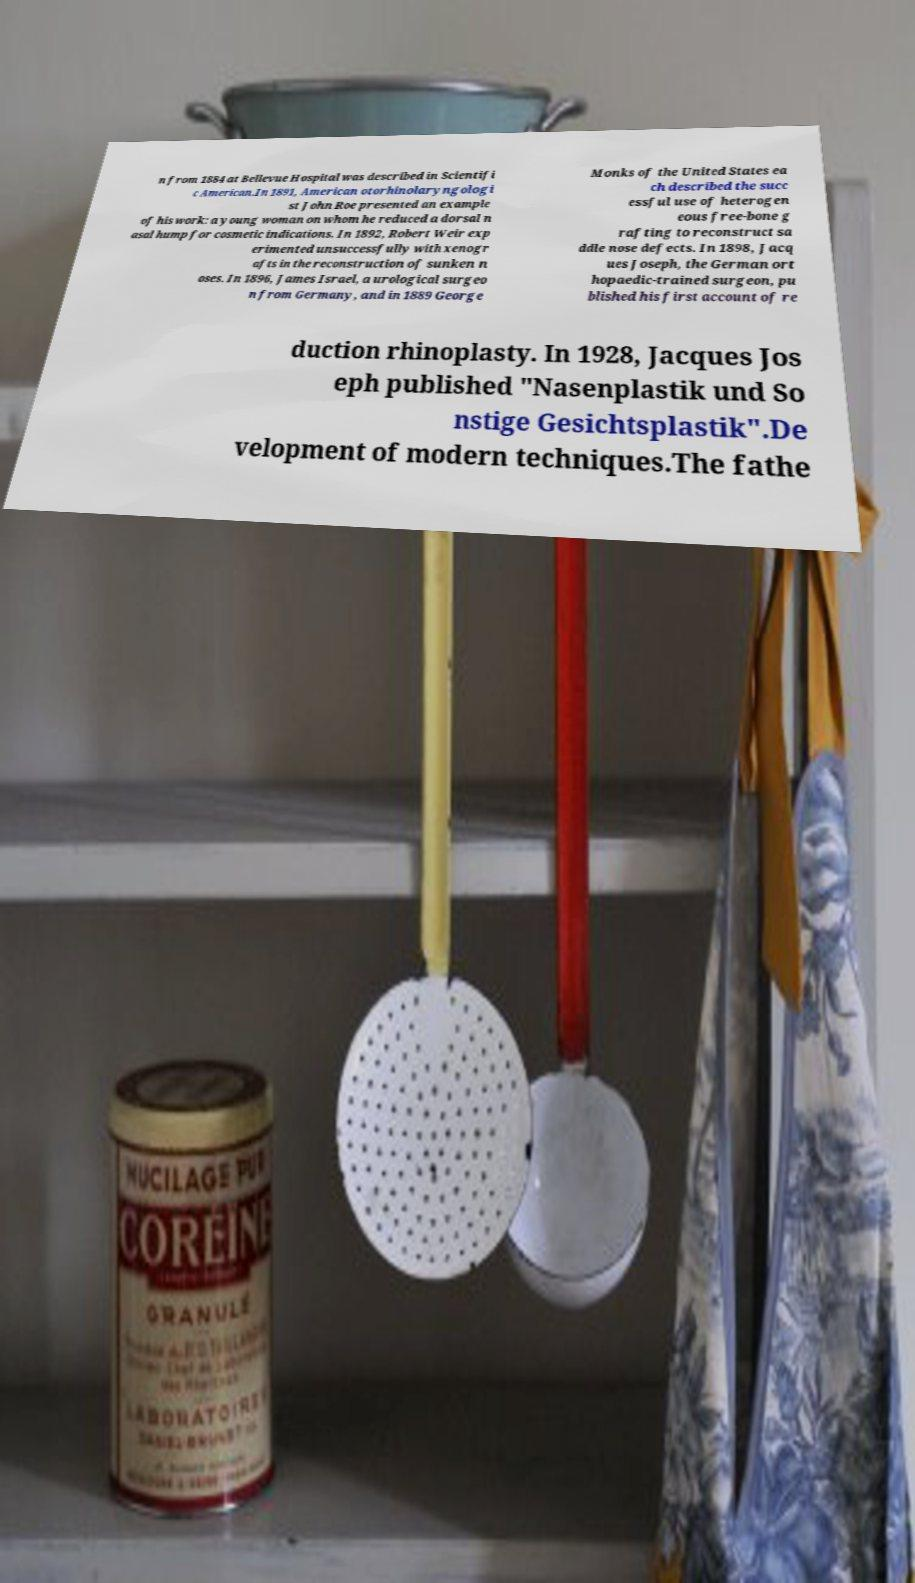Please identify and transcribe the text found in this image. n from 1884 at Bellevue Hospital was described in Scientifi c American.In 1891, American otorhinolaryngologi st John Roe presented an example of his work: a young woman on whom he reduced a dorsal n asal hump for cosmetic indications. In 1892, Robert Weir exp erimented unsuccessfully with xenogr afts in the reconstruction of sunken n oses. In 1896, James Israel, a urological surgeo n from Germany, and in 1889 George Monks of the United States ea ch described the succ essful use of heterogen eous free-bone g rafting to reconstruct sa ddle nose defects. In 1898, Jacq ues Joseph, the German ort hopaedic-trained surgeon, pu blished his first account of re duction rhinoplasty. In 1928, Jacques Jos eph published "Nasenplastik und So nstige Gesichtsplastik".De velopment of modern techniques.The fathe 